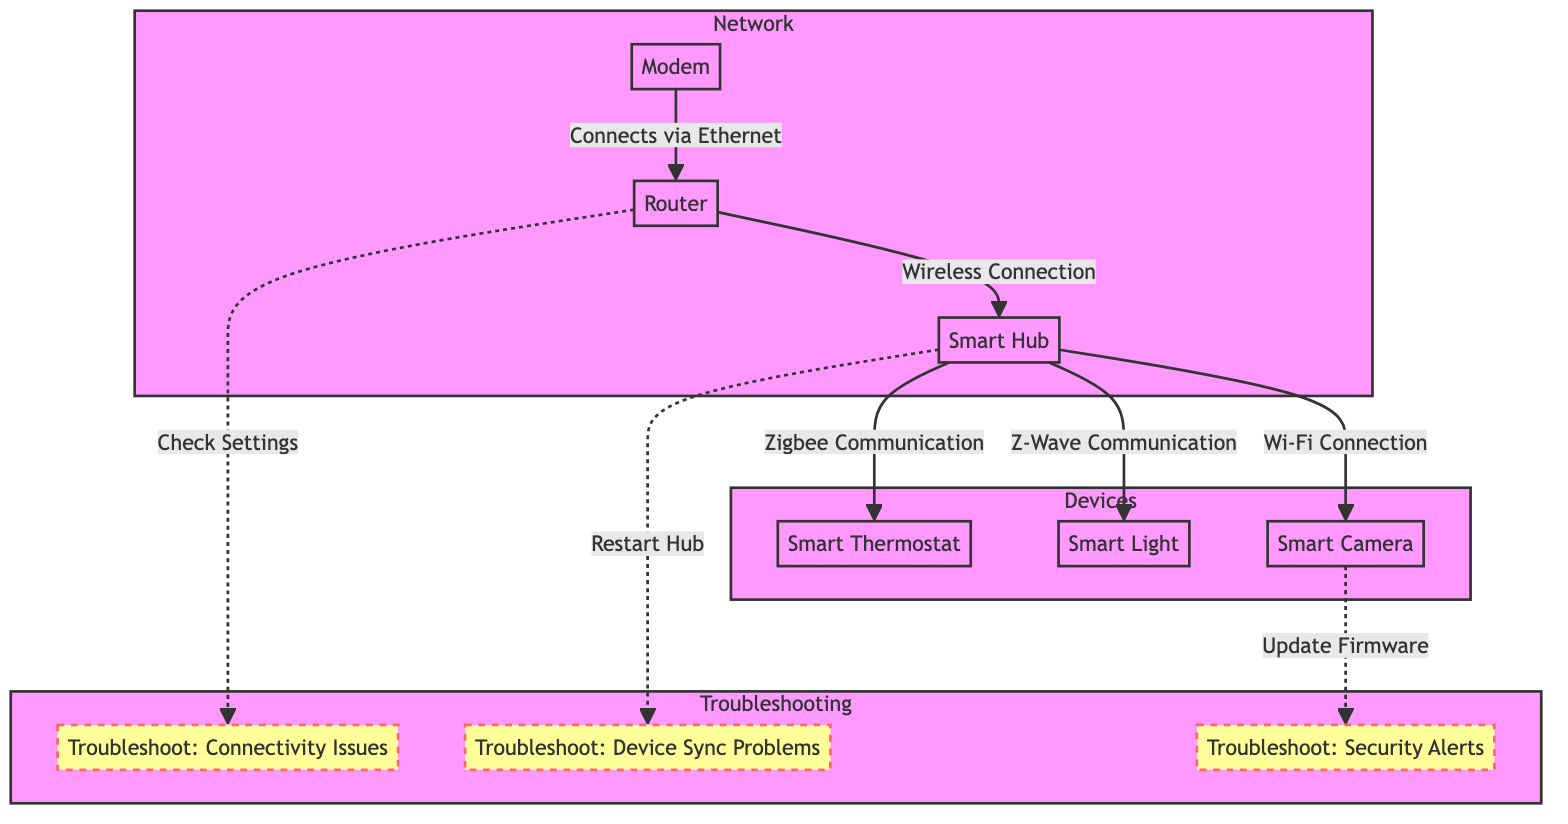What's the total number of nodes in the diagram? The diagram contains seven distinct nodes, namely Modem, Router, Smart Hub, Smart Thermostat, Smart Light, Smart Camera, and the troubleshooting nodes.
Answer: Seven What type of connection does the Router use to connect to the Modem? The diagram specifies that the Router is connected to the Modem via an Ethernet connection, indicated by the label on the arrow between these two nodes.
Answer: Ethernet Which device communicates with the Smart Hub via Zigbee? The diagram shows that the Smart Thermostat communicates with the Smart Hub using Zigbee, as indicated by the connecting line and label between these two devices.
Answer: Smart Thermostat What troubleshooting step is related to the Router? The diagram indicates that checking settings is the troubleshooting step related to the Router, as shown by the dashed line leading from the Router to the corresponding troubleshooting node.
Answer: Check Settings How does the Smart Hub communicate with the Smart Light? The Smart Hub communicates with the Smart Light using Z-Wave, as indicated by the label on the connecting line between these two nodes.
Answer: Z-Wave What is the troubleshooting step for device synchronization issues? The diagram highlights that the troubleshooting step for device synchronization problems is to restart the Hub, which connects to the troubleshooting node labeled for device sync issues.
Answer: Restart Hub What is the relationship between the Smart Camera and the troubleshooting security node? The diagram shows that the relationship involves updating the Firmware, as depicted by the dashed line connecting the Smart Camera to the troubleshooting security node.
Answer: Update Firmware How many troubleshooting steps are outlined in the diagram? The diagram clearly specifies three distinct troubleshooting steps: Connectivity Issues, Device Sync Problems, and Security Alerts, indicating that there are three troubleshooting nodes.
Answer: Three What type of devices are connected to the Smart Hub? The diagram delineates that the Smart Hub is connected to three devices: Smart Thermostat, Smart Light, and Smart Camera, as shown by their respective connecting lines.
Answer: Three devices 